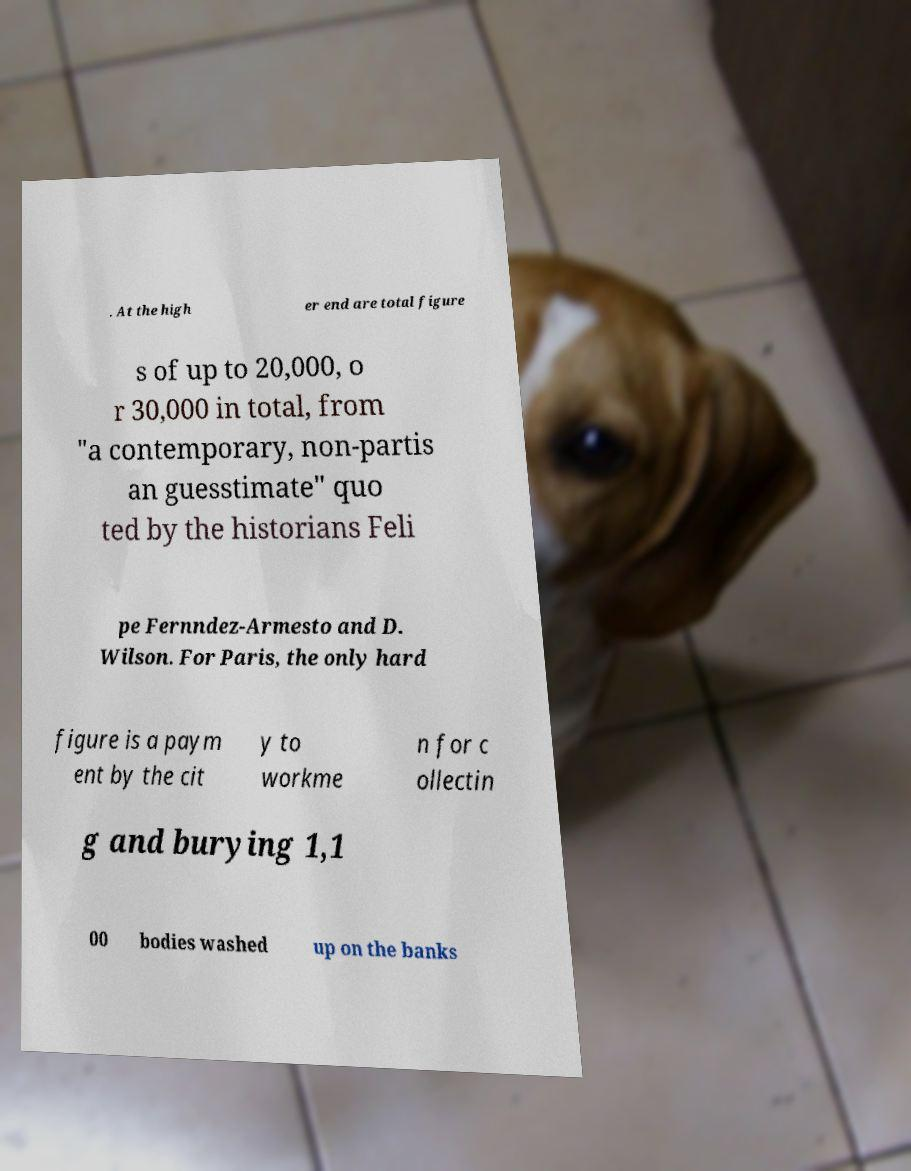Could you extract and type out the text from this image? . At the high er end are total figure s of up to 20,000, o r 30,000 in total, from "a contemporary, non-partis an guesstimate" quo ted by the historians Feli pe Fernndez-Armesto and D. Wilson. For Paris, the only hard figure is a paym ent by the cit y to workme n for c ollectin g and burying 1,1 00 bodies washed up on the banks 